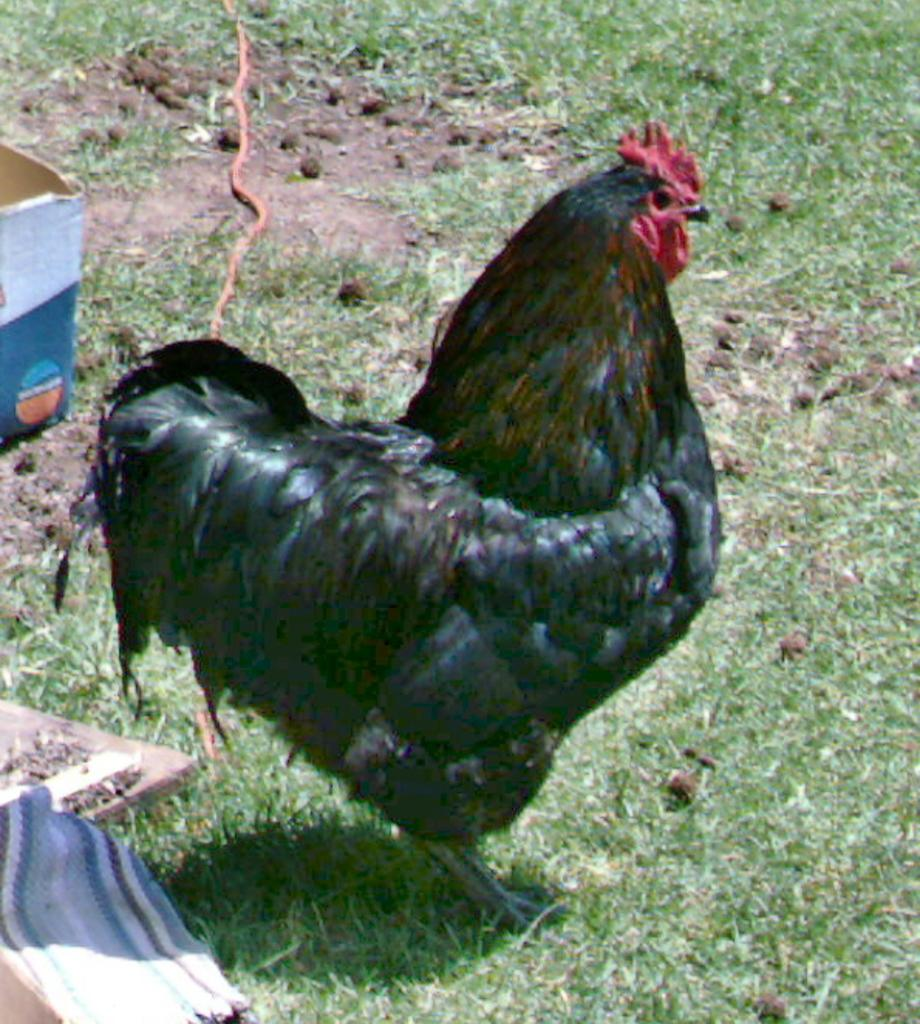What animal is the main subject of the picture? There is a black color Rooster in the picture. What is the Rooster standing on? The Rooster is standing on the grass ground. What can be seen in the background of the picture? There is a cardboard box in the background of the picture. What color is the ink used to draw the hands in the image? There are no hands or ink present in the image; it features a black Rooster standing on grass with a cardboard box in the background. 